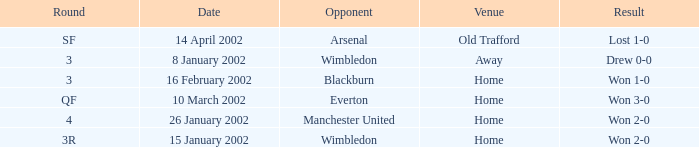What is the Venue with a Date with 14 april 2002? Old Trafford. 